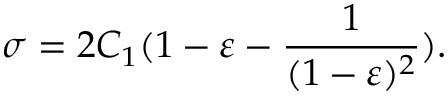<formula> <loc_0><loc_0><loc_500><loc_500>\sigma = 2 C _ { 1 } ( 1 - \varepsilon - \frac { 1 } { ( 1 - \varepsilon ) ^ { 2 } } ) .</formula> 